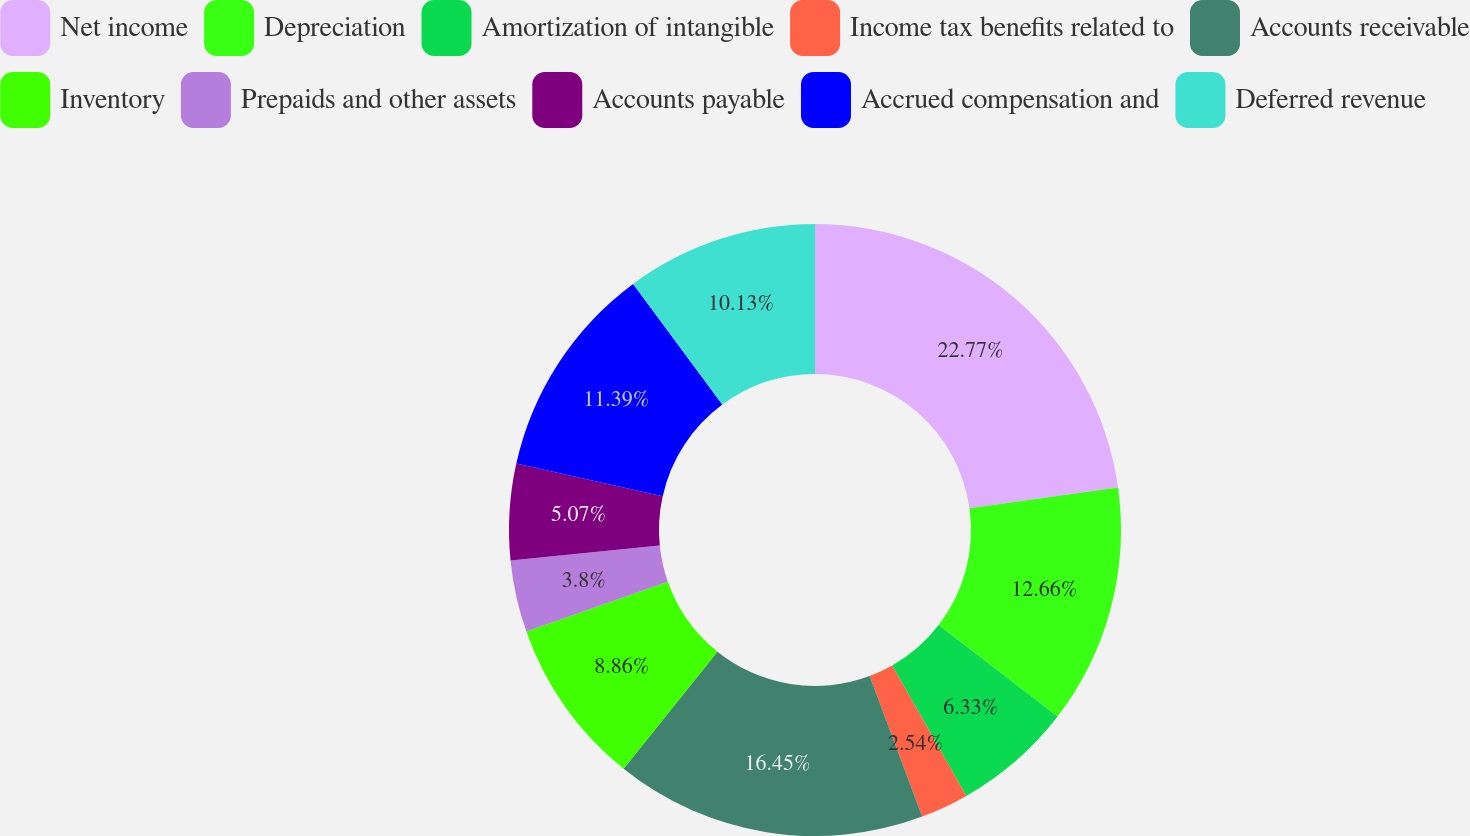Convert chart to OTSL. <chart><loc_0><loc_0><loc_500><loc_500><pie_chart><fcel>Net income<fcel>Depreciation<fcel>Amortization of intangible<fcel>Income tax benefits related to<fcel>Accounts receivable<fcel>Inventory<fcel>Prepaids and other assets<fcel>Accounts payable<fcel>Accrued compensation and<fcel>Deferred revenue<nl><fcel>22.78%<fcel>12.66%<fcel>6.33%<fcel>2.54%<fcel>16.45%<fcel>8.86%<fcel>3.8%<fcel>5.07%<fcel>11.39%<fcel>10.13%<nl></chart> 